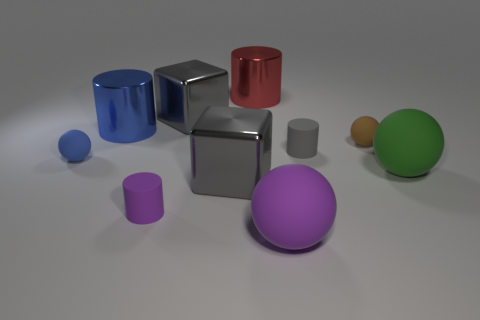Subtract 1 spheres. How many spheres are left? 3 Subtract all cylinders. How many objects are left? 6 Add 7 large gray blocks. How many large gray blocks are left? 9 Add 3 brown spheres. How many brown spheres exist? 4 Subtract 1 green balls. How many objects are left? 9 Subtract all tiny blue balls. Subtract all small gray blocks. How many objects are left? 9 